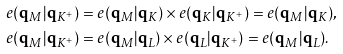Convert formula to latex. <formula><loc_0><loc_0><loc_500><loc_500>& e ( \mathbf q _ { M } | \mathbf q _ { K ^ { + } } ) = e ( \mathbf q _ { M } | \mathbf q _ { K } ) \times e ( \mathbf q _ { K } | \mathbf q _ { K ^ { + } } ) = e ( \mathbf q _ { M } | \mathbf q _ { K } ) , \\ & e ( \mathbf q _ { M } | \mathbf q _ { K ^ { + } } ) = e ( \mathbf q _ { M } | \mathbf q _ { L } ) \times e ( \mathbf q _ { L } | \mathbf q _ { K ^ { + } } ) = e ( \mathbf q _ { M } | \mathbf q _ { L } ) . \\</formula> 